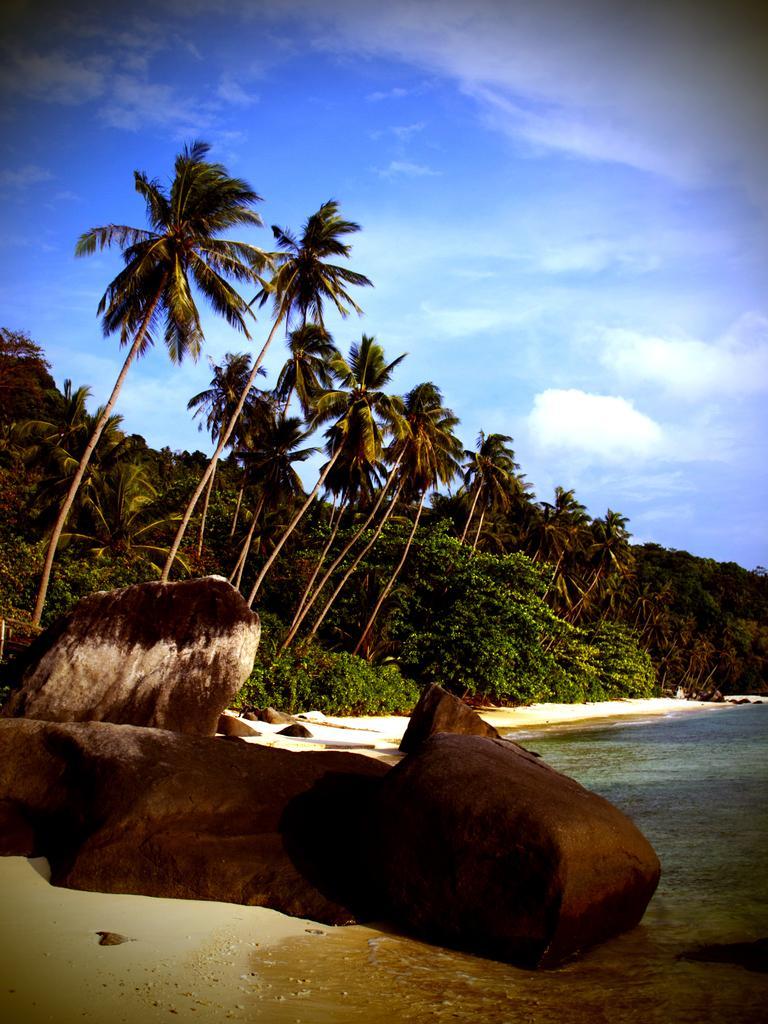Describe this image in one or two sentences. In this picture I can see trees and rocks. On the right side I can see water and the sky in the background. 